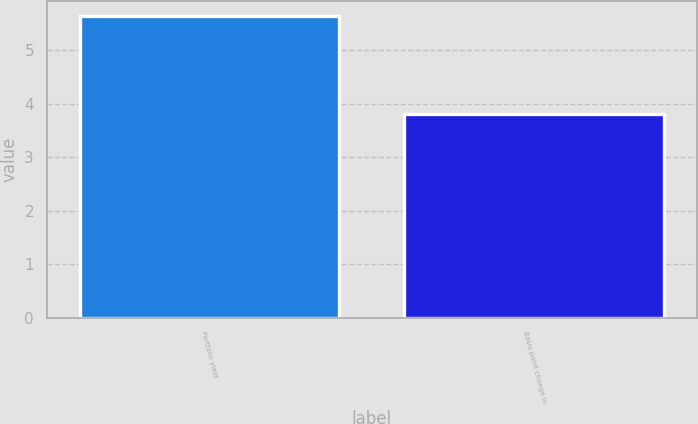<chart> <loc_0><loc_0><loc_500><loc_500><bar_chart><fcel>Portfolio yield<fcel>Basis point change in<nl><fcel>5.63<fcel>3.81<nl></chart> 